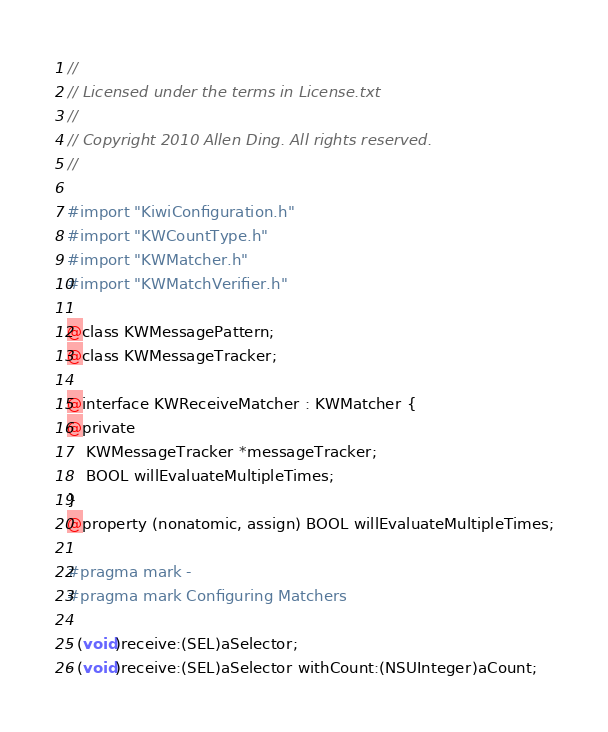Convert code to text. <code><loc_0><loc_0><loc_500><loc_500><_C_>//
// Licensed under the terms in License.txt
//
// Copyright 2010 Allen Ding. All rights reserved.
//

#import "KiwiConfiguration.h"
#import "KWCountType.h"
#import "KWMatcher.h"
#import "KWMatchVerifier.h"

@class KWMessagePattern;
@class KWMessageTracker;

@interface KWReceiveMatcher : KWMatcher {
@private
    KWMessageTracker *messageTracker;
    BOOL willEvaluateMultipleTimes;
}
@property (nonatomic, assign) BOOL willEvaluateMultipleTimes;

#pragma mark -
#pragma mark Configuring Matchers

- (void)receive:(SEL)aSelector;
- (void)receive:(SEL)aSelector withCount:(NSUInteger)aCount;</code> 